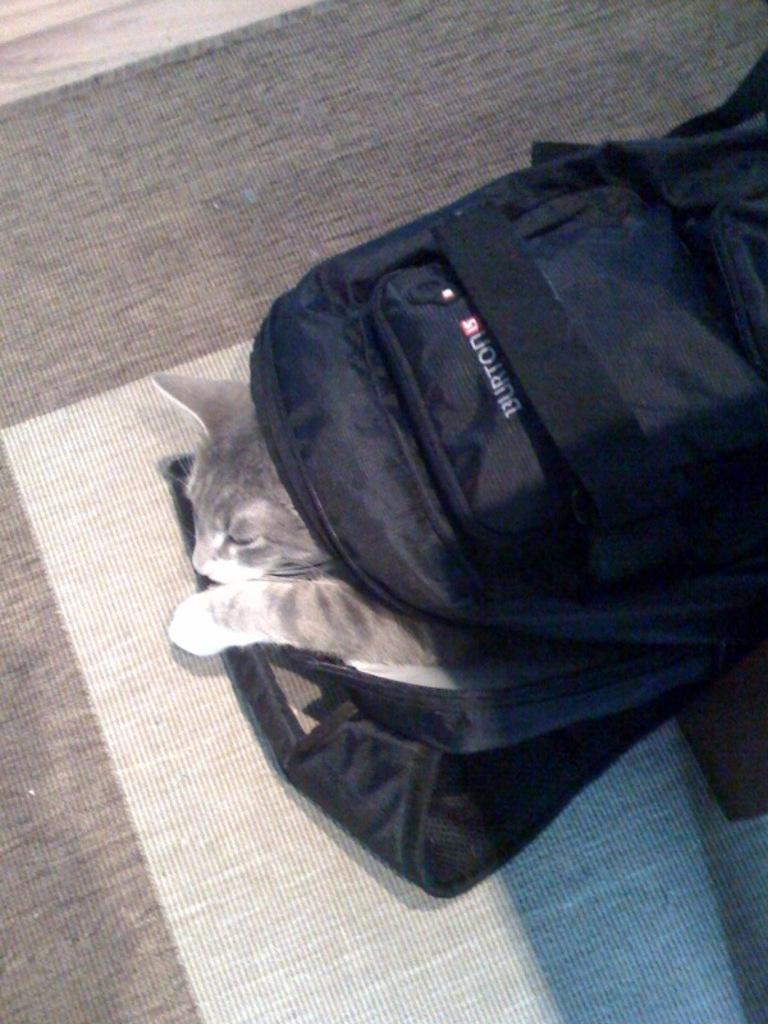What is the color of the bag in the image? The bag in the image is black. What is inside the bag? There is a cat in the bag. What type of doll is being served for breakfast in the image? There is no doll or breakfast present in the image; it only features a black color bag with a cat inside. 